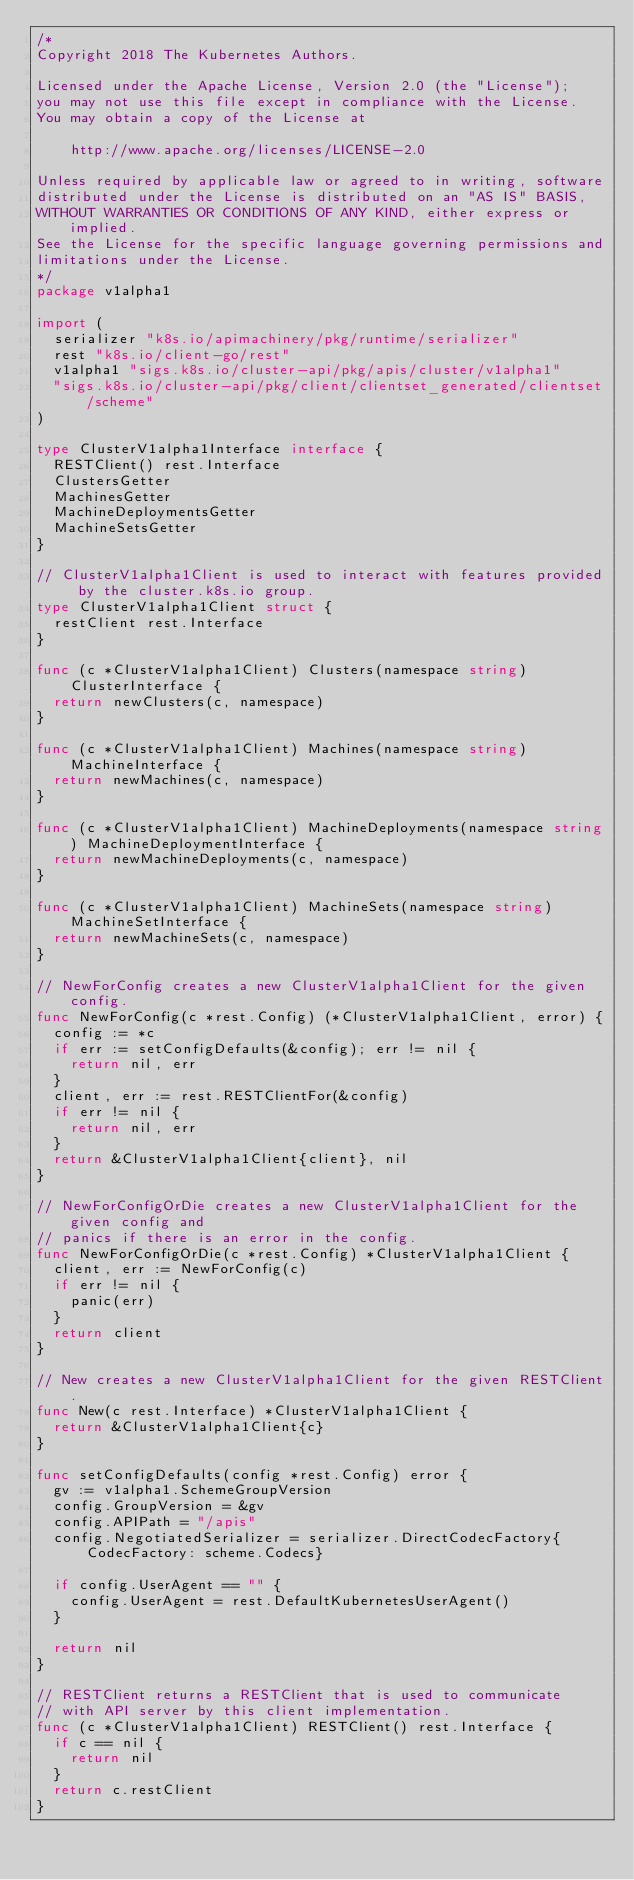Convert code to text. <code><loc_0><loc_0><loc_500><loc_500><_Go_>/*
Copyright 2018 The Kubernetes Authors.

Licensed under the Apache License, Version 2.0 (the "License");
you may not use this file except in compliance with the License.
You may obtain a copy of the License at

    http://www.apache.org/licenses/LICENSE-2.0

Unless required by applicable law or agreed to in writing, software
distributed under the License is distributed on an "AS IS" BASIS,
WITHOUT WARRANTIES OR CONDITIONS OF ANY KIND, either express or implied.
See the License for the specific language governing permissions and
limitations under the License.
*/
package v1alpha1

import (
	serializer "k8s.io/apimachinery/pkg/runtime/serializer"
	rest "k8s.io/client-go/rest"
	v1alpha1 "sigs.k8s.io/cluster-api/pkg/apis/cluster/v1alpha1"
	"sigs.k8s.io/cluster-api/pkg/client/clientset_generated/clientset/scheme"
)

type ClusterV1alpha1Interface interface {
	RESTClient() rest.Interface
	ClustersGetter
	MachinesGetter
	MachineDeploymentsGetter
	MachineSetsGetter
}

// ClusterV1alpha1Client is used to interact with features provided by the cluster.k8s.io group.
type ClusterV1alpha1Client struct {
	restClient rest.Interface
}

func (c *ClusterV1alpha1Client) Clusters(namespace string) ClusterInterface {
	return newClusters(c, namespace)
}

func (c *ClusterV1alpha1Client) Machines(namespace string) MachineInterface {
	return newMachines(c, namespace)
}

func (c *ClusterV1alpha1Client) MachineDeployments(namespace string) MachineDeploymentInterface {
	return newMachineDeployments(c, namespace)
}

func (c *ClusterV1alpha1Client) MachineSets(namespace string) MachineSetInterface {
	return newMachineSets(c, namespace)
}

// NewForConfig creates a new ClusterV1alpha1Client for the given config.
func NewForConfig(c *rest.Config) (*ClusterV1alpha1Client, error) {
	config := *c
	if err := setConfigDefaults(&config); err != nil {
		return nil, err
	}
	client, err := rest.RESTClientFor(&config)
	if err != nil {
		return nil, err
	}
	return &ClusterV1alpha1Client{client}, nil
}

// NewForConfigOrDie creates a new ClusterV1alpha1Client for the given config and
// panics if there is an error in the config.
func NewForConfigOrDie(c *rest.Config) *ClusterV1alpha1Client {
	client, err := NewForConfig(c)
	if err != nil {
		panic(err)
	}
	return client
}

// New creates a new ClusterV1alpha1Client for the given RESTClient.
func New(c rest.Interface) *ClusterV1alpha1Client {
	return &ClusterV1alpha1Client{c}
}

func setConfigDefaults(config *rest.Config) error {
	gv := v1alpha1.SchemeGroupVersion
	config.GroupVersion = &gv
	config.APIPath = "/apis"
	config.NegotiatedSerializer = serializer.DirectCodecFactory{CodecFactory: scheme.Codecs}

	if config.UserAgent == "" {
		config.UserAgent = rest.DefaultKubernetesUserAgent()
	}

	return nil
}

// RESTClient returns a RESTClient that is used to communicate
// with API server by this client implementation.
func (c *ClusterV1alpha1Client) RESTClient() rest.Interface {
	if c == nil {
		return nil
	}
	return c.restClient
}
</code> 